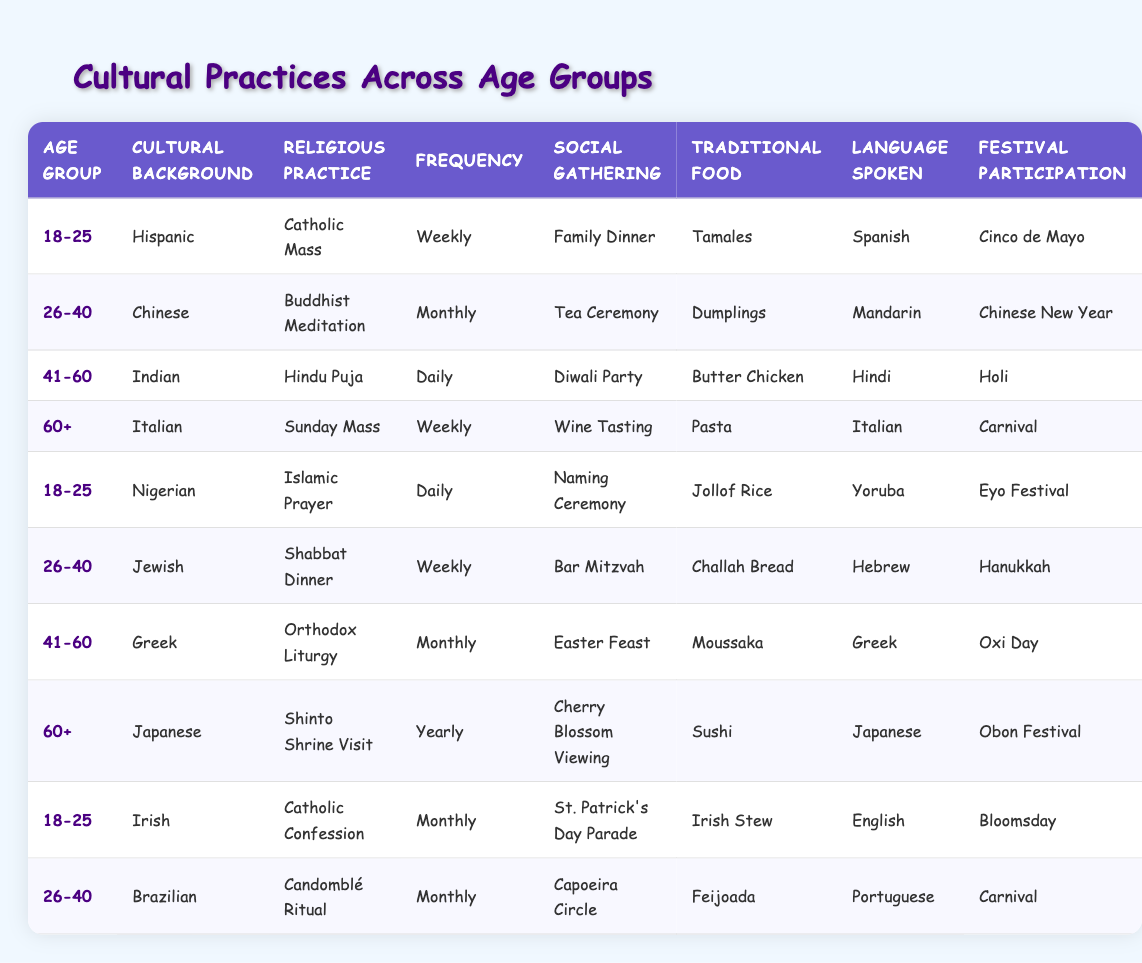What cultural background is associated with the 41-60 age group? In the table, the row that corresponds to the 41-60 age group lists "Indian" under the Cultural Background column.
Answer: Indian What is the frequency of the religious practice for the Nigerian cultural background? Referring to the table, the Nigerian cultural background is listed under the 18-25 age group, where the religious practice is "Islamic Prayer" and the frequency is "Daily."
Answer: Daily How many different languages are spoken across all age groups listed in the table? By looking through the Language Spoken column, there are five distinct languages mentioned: Spanish, Mandarin, Hindi, Italian, Yoruba, Hebrew, Greek, and Japanese. That's a total of eight different languages.
Answer: Eight Are there any participants from the 60+ age group who practice a religious service yearly? From the table, the Japanese cultural background in the 60+ age group practices "Shinto Shrine Visit," which has a frequency of "Yearly," making this statement true.
Answer: Yes What type of traditional food is associated with the social gathering of a "Diwali Party"? Under the age group 41-60 for the Indian cultural background, the corresponding traditional food for the social gathering "Diwali Party" is "Butter Chicken."
Answer: Butter Chicken Which age group participates in festivals most frequently? By analyzing the values for festival participation, we see that the 41-60 age group (Hindu) participates in "Holi," which is celebrated annually, while the 18-25 group has two entries but those represent different festivals. Therefore, we find that multiple groups participate annually, but hind us is the most consistent due to daily practices and multiple entries associated with festivities.
Answer: Multiple Is there a cultural background associated with both the 26-40 age group and the frequency of monthly practices? The 26-40 age group consists of a Chinese cultural background practicing "Buddhist Meditation" and a Brazilian cultural background practicing "Candomblé Ritual," both of which have a frequency of "Monthly." Therefore, the answer is yes.
Answer: Yes How often do individuals in the 18-25 age group gather socially for "Family Dinner"? The Hispanic cultural background in the 18-25 age group includes social gathering "Family Dinner," with the frequency of religious practice being "Weekly." Thus, the social gathering also occurs weekly.
Answer: Weekly What is the most prevalent religious practice among participants aged 41-60? The data indicates that in the 41-60 age group, there are two different religious practices listed. The most prevalent is "Hindu Puja," being practiced daily, making it the most engaged religious practice in this group.
Answer: Hindu Puja 